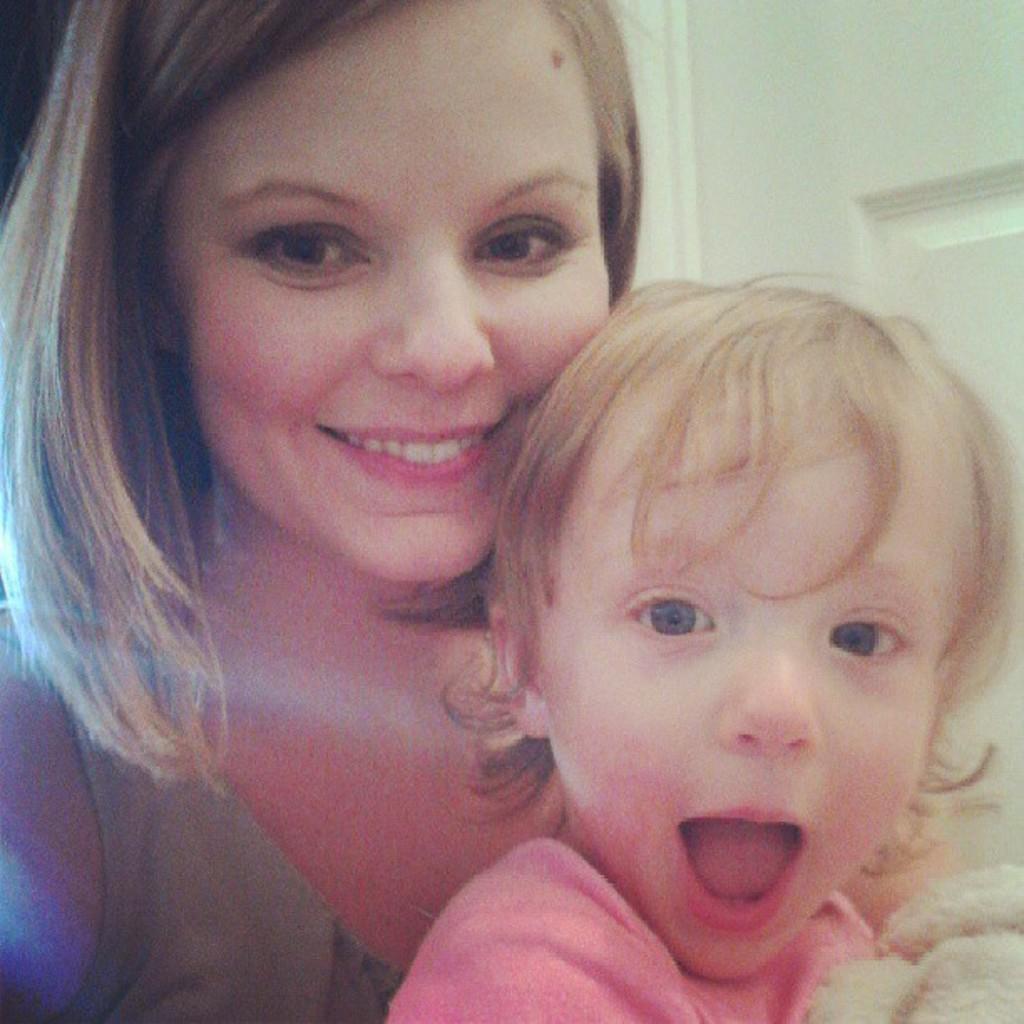Can you describe this image briefly? In the center of the image there is a girl and there is a lady. In the background of the image there is a door. 